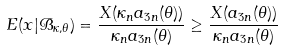<formula> <loc_0><loc_0><loc_500><loc_500>E ( x | \mathcal { B } _ { \kappa , \theta } ) = \frac { X ( \kappa _ { n } a _ { 3 n } ( \theta ) ) } { \kappa _ { n } a _ { 3 n } ( \theta ) } \geq \frac { X ( a _ { 3 n } ( \theta ) ) } { \kappa _ { n } a _ { 3 n } ( \theta ) }</formula> 